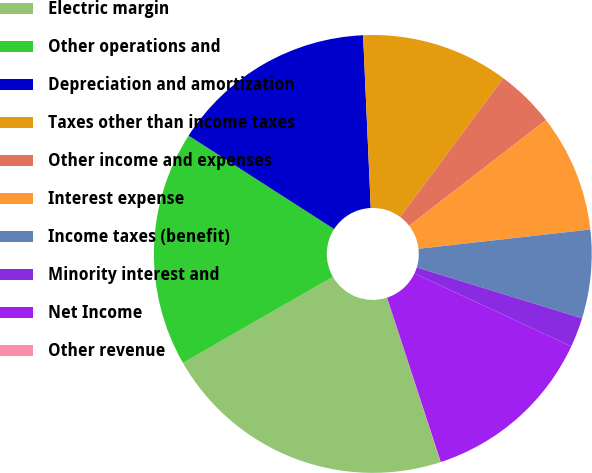Convert chart to OTSL. <chart><loc_0><loc_0><loc_500><loc_500><pie_chart><fcel>Electric margin<fcel>Other operations and<fcel>Depreciation and amortization<fcel>Taxes other than income taxes<fcel>Other income and expenses<fcel>Interest expense<fcel>Income taxes (benefit)<fcel>Minority interest and<fcel>Net Income<fcel>Other revenue<nl><fcel>21.71%<fcel>17.38%<fcel>15.21%<fcel>10.87%<fcel>4.36%<fcel>8.7%<fcel>6.53%<fcel>2.19%<fcel>13.04%<fcel>0.02%<nl></chart> 